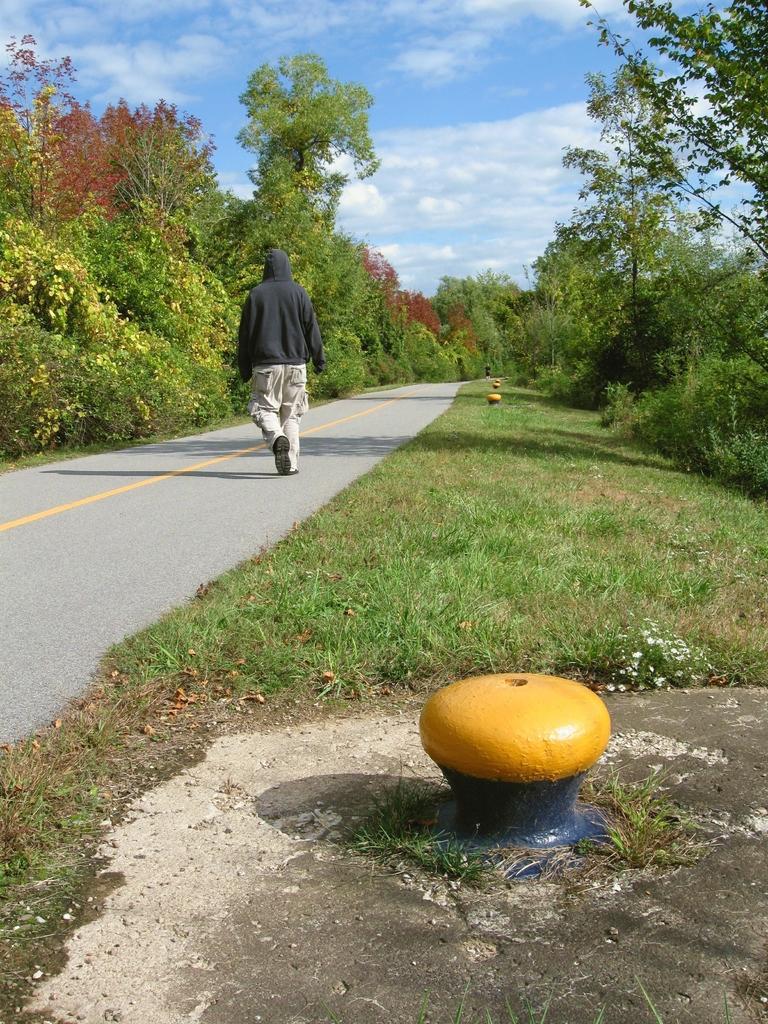Please provide a concise description of this image. In the picture I can see a person is walking on the road. I can also see some yellow color objects, the grass, plants, trees and the sky. 